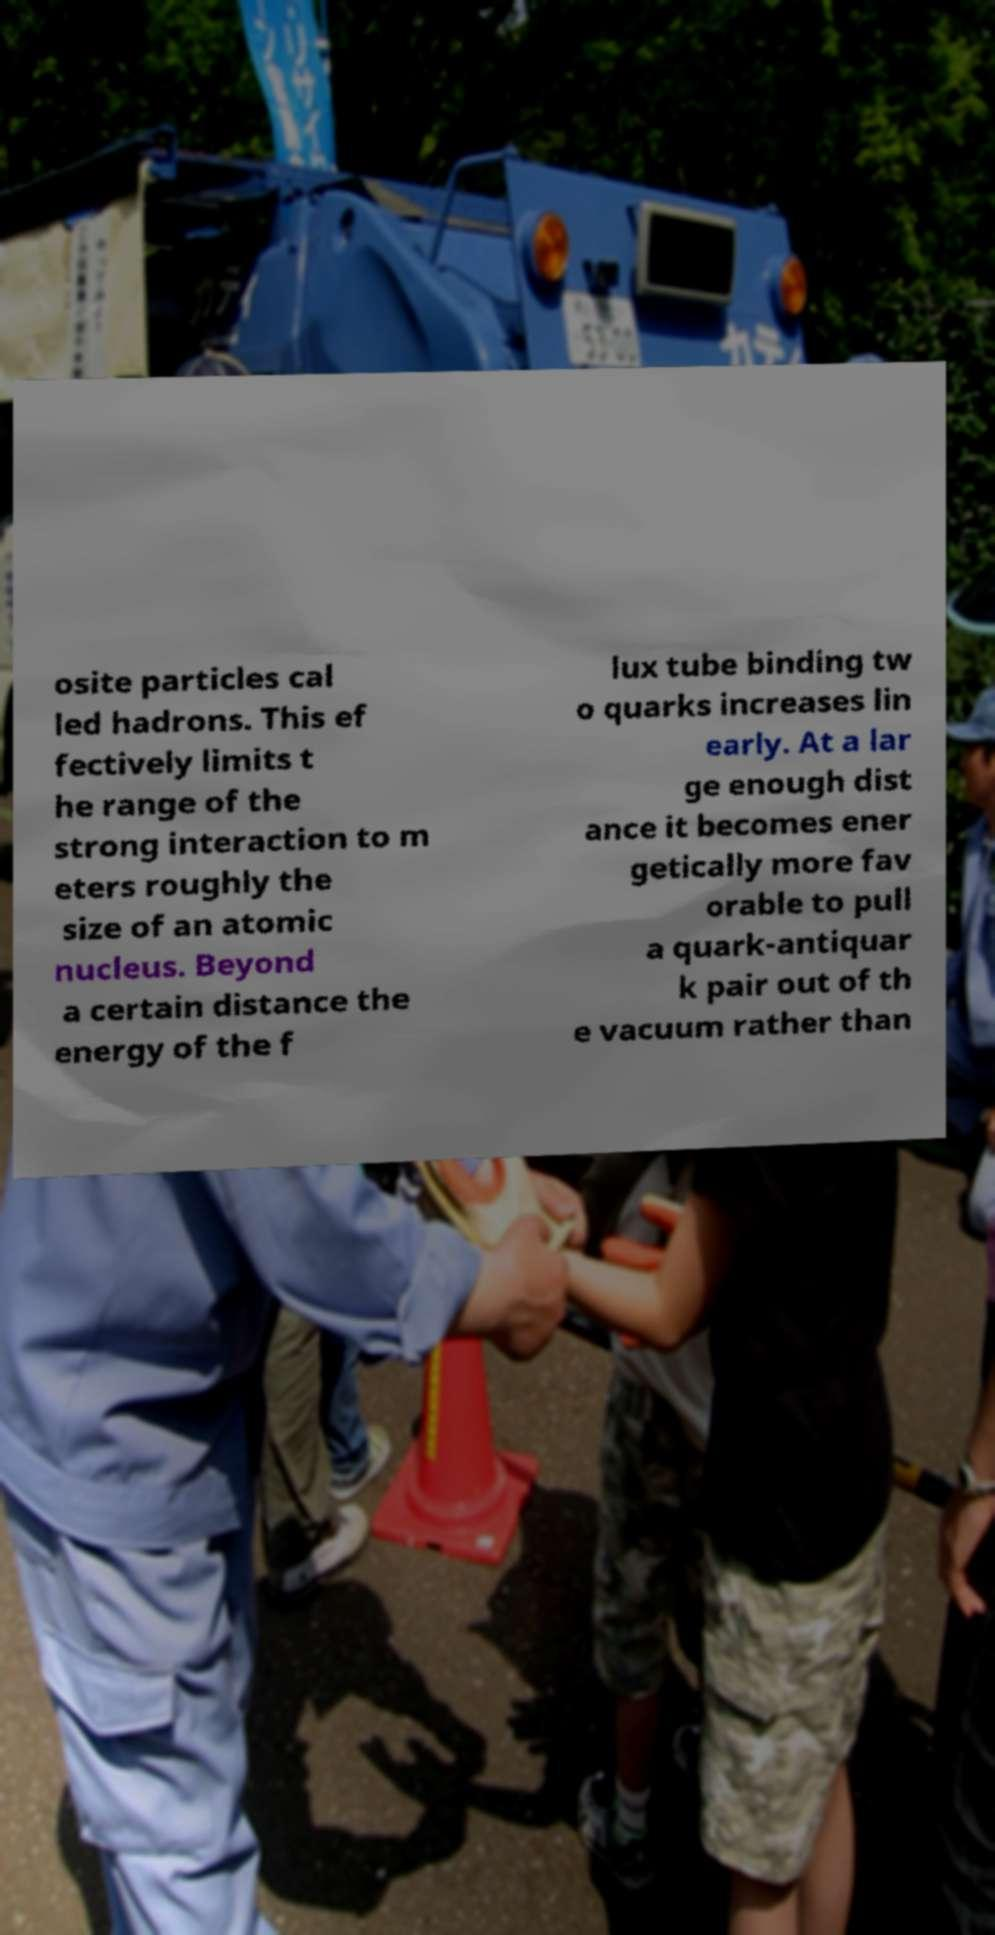Please read and relay the text visible in this image. What does it say? osite particles cal led hadrons. This ef fectively limits t he range of the strong interaction to m eters roughly the size of an atomic nucleus. Beyond a certain distance the energy of the f lux tube binding tw o quarks increases lin early. At a lar ge enough dist ance it becomes ener getically more fav orable to pull a quark-antiquar k pair out of th e vacuum rather than 